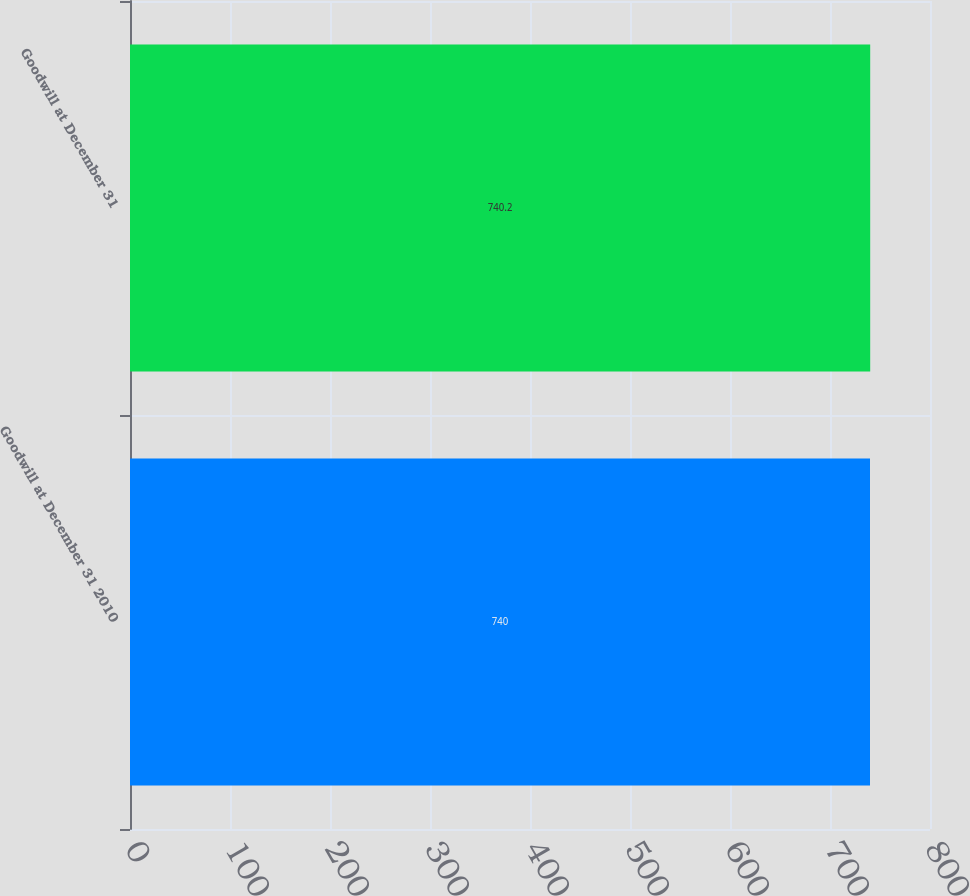<chart> <loc_0><loc_0><loc_500><loc_500><bar_chart><fcel>Goodwill at December 31 2010<fcel>Goodwill at December 31<nl><fcel>740<fcel>740.2<nl></chart> 